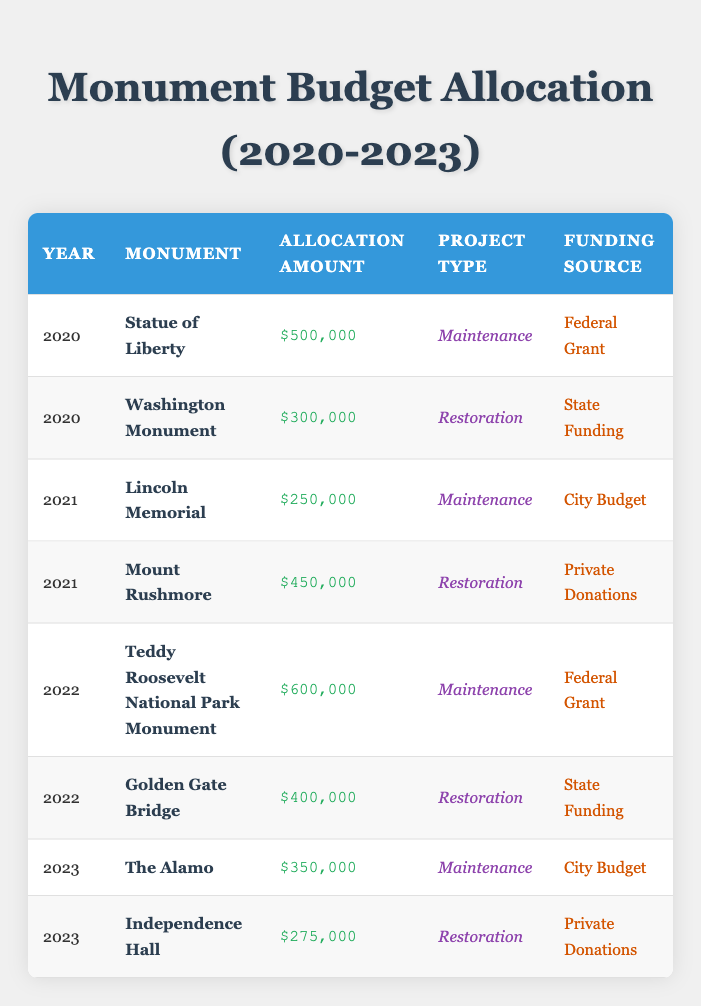What is the total budget allocation for monument maintenance in 2020? In 2020, there are two maintenance projects: the Statue of Liberty with an allocation of 500,000 and the Washington Monument is a restoration project, so we do not consider it. Therefore, the total budget for maintenance in that year is 500,000.
Answer: 500,000 Which monument received the highest allocation amount for restoration in 2021? In 2021, there are two monuments categorized as restoration projects: the Washington Monument with 300,000 and Mount Rushmore with 450,000. The highest allocation for restoration in that year is for Mount Rushmore at 450,000.
Answer: Mount Rushmore Is it true that all the monuments funded by private donations are for restoration projects? The table shows two monuments funded by private donations: Mount Rushmore in 2021 (restoration) and Independence Hall in 2023 (restoration). Both monuments funded this way are indeed for restoration projects, making the statement true.
Answer: Yes What is the average allocation amount for maintenance projects across the years provided in the table? The maintenance projects are: Statue of Liberty (500,000 in 2020), Lincoln Memorial (250,000 in 2021), Teddy Roosevelt National Park Monument (600,000 in 2022), and The Alamo (350,000 in 2023). The total allocation is 500,000 + 250,000 + 600,000 + 350,000 = 1,700,000. There are 4 maintenance projects, so the average is 1,700,000 / 4 = 425,000.
Answer: 425,000 In which year was the allocation amount for restoration the lowest? The restoration allocations are for the Washington Monument (300,000 in 2020), Mount Rushmore (450,000 in 2021), Golden Gate Bridge (400,000 in 2022), and Independence Hall (275,000 in 2023). Comparing these amounts, the lowest allocation for restoration is 275,000 in 2023.
Answer: 2023 